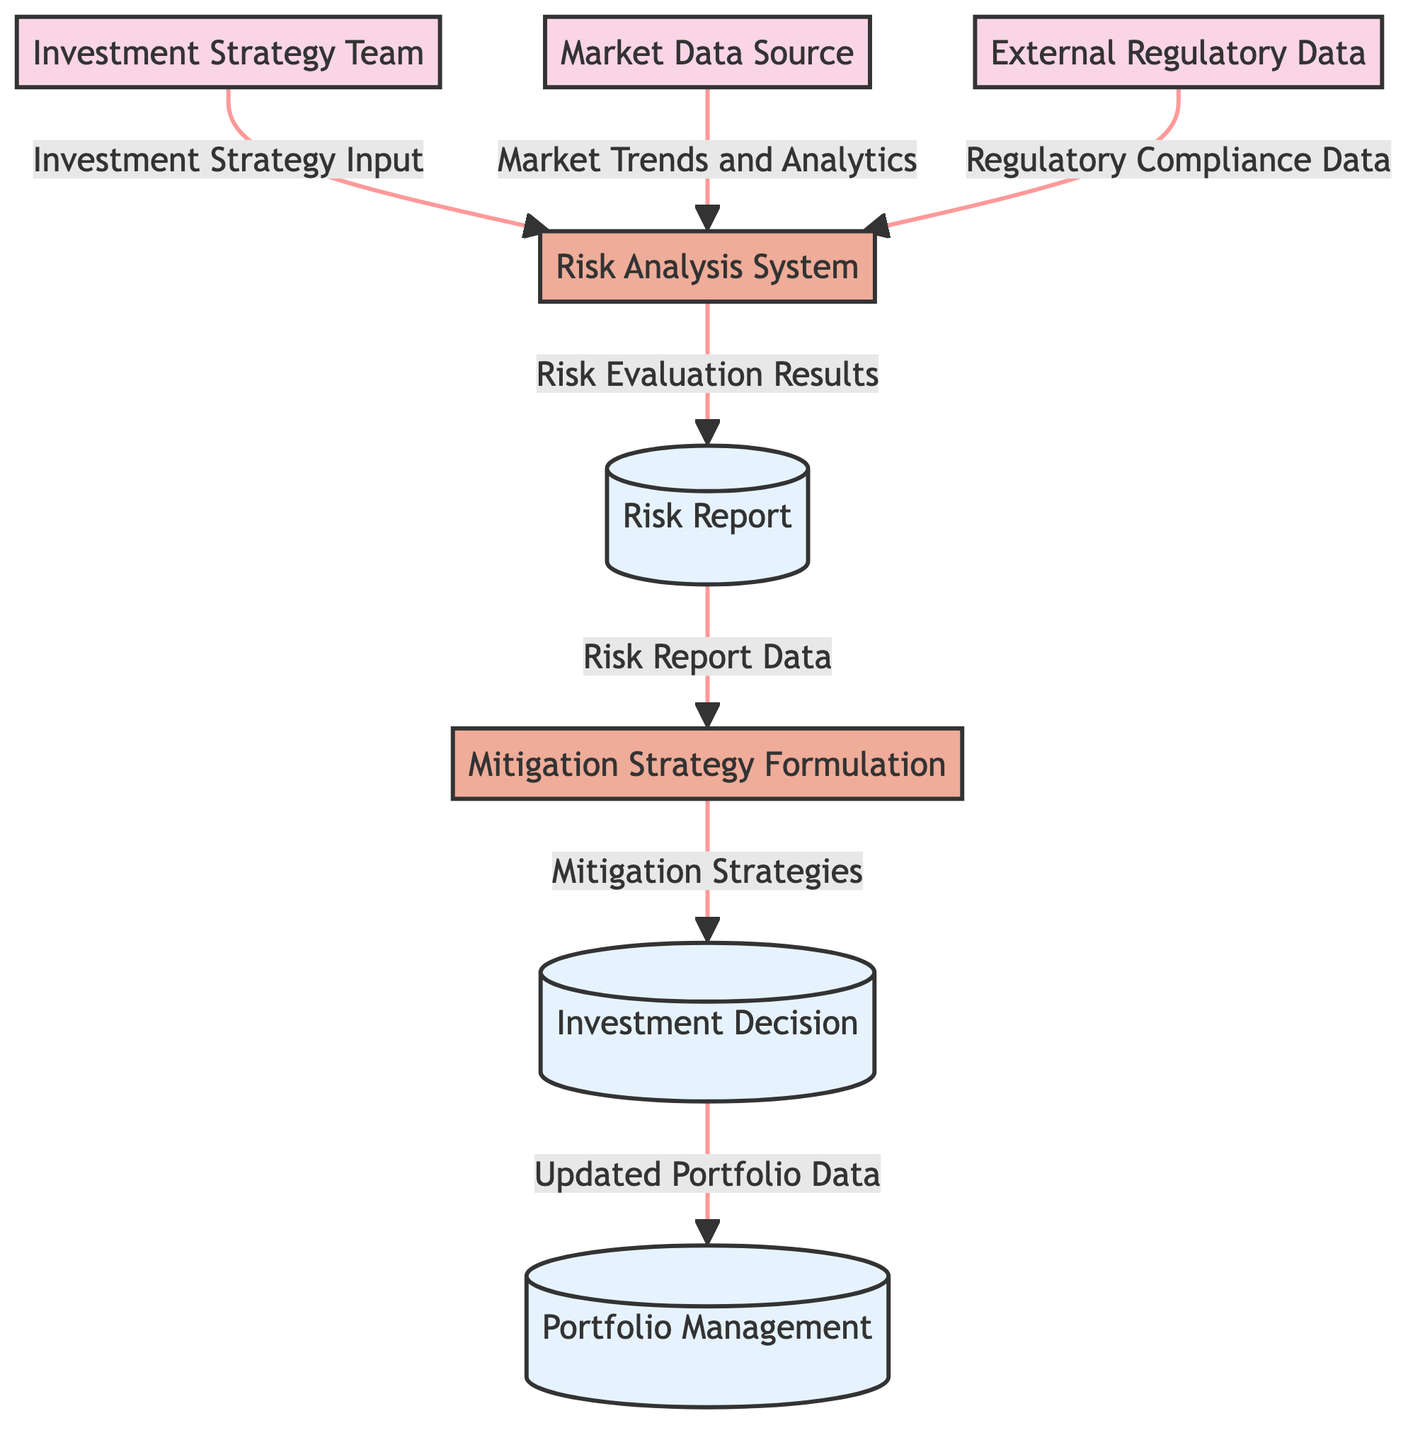What is the source of the "Investment Strategy Input"? The source of "Investment Strategy Input" is the "Investment Strategy Team," which is an external entity responsible for providing the initial input to the risk analysis process.
Answer: Investment Strategy Team How many processes are represented in the diagram? The diagram contains two processes: "Risk Analysis System" and "Mitigation Strategy Formulation." Counting these processes gives a total of two.
Answer: 2 What type of data store is "Portfolio Management"? "Portfolio Management" is classified as a data store in the diagram, indicating it serves as a repository to hold data related to portfolio management.
Answer: Data Store What is the destination of "Risk Evaluation Results"? The destination of "Risk Evaluation Results" is the "Risk Report," which receives the evaluation results from the risk analysis process for further processing.
Answer: Risk Report What type of data is sent from "Mitigation Strategy Formulation" to "Investment Decision"? The data type sent from "Mitigation Strategy Formulation" to "Investment Decision" is "Mitigation Strategies," which refers to the strategies developed to mitigate risks based on analysis results.
Answer: Mitigation Strategies Which external entity provides "Market Trends and Analytics"? The external entity that provides "Market Trends and Analytics" is the "Market Data Source," which supplies crucial market data for the risk analysis process.
Answer: Market Data Source What is the relationship between "Risk Report Data" and "Mitigation Strategy Formulation"? "Risk Report Data" serves as an input to "Mitigation Strategy Formulation," indicating that the data extracted from the risk report informs the development of mitigation strategies.
Answer: Input Which process receives data from both the "Market Data Source" and "External Regulatory Data"? The "Risk Analysis System" process receives data from both the "Market Data Source," providing market trends, and "External Regulatory Data," which contributes compliance data for analysis.
Answer: Risk Analysis System 